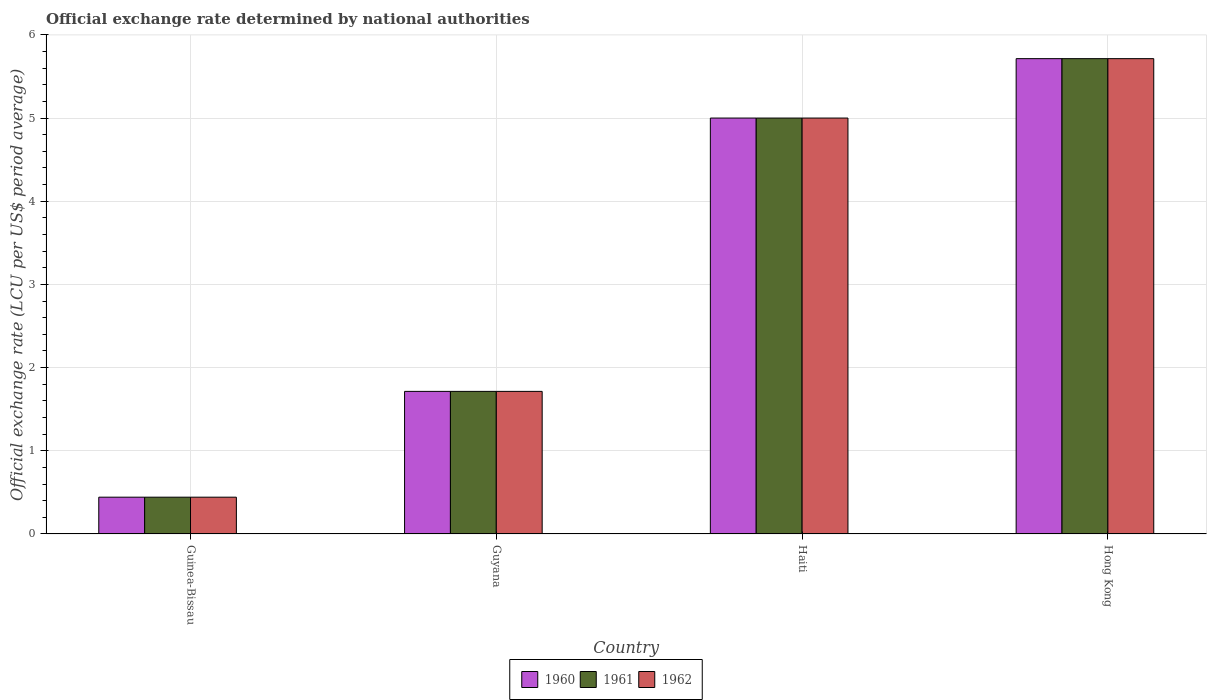Are the number of bars on each tick of the X-axis equal?
Offer a terse response. Yes. How many bars are there on the 2nd tick from the left?
Provide a short and direct response. 3. What is the label of the 1st group of bars from the left?
Make the answer very short. Guinea-Bissau. In how many cases, is the number of bars for a given country not equal to the number of legend labels?
Make the answer very short. 0. What is the official exchange rate in 1962 in Guinea-Bissau?
Give a very brief answer. 0.44. Across all countries, what is the maximum official exchange rate in 1960?
Offer a very short reply. 5.71. Across all countries, what is the minimum official exchange rate in 1960?
Make the answer very short. 0.44. In which country was the official exchange rate in 1960 maximum?
Your answer should be compact. Hong Kong. In which country was the official exchange rate in 1962 minimum?
Provide a succinct answer. Guinea-Bissau. What is the total official exchange rate in 1960 in the graph?
Your answer should be compact. 12.87. What is the difference between the official exchange rate in 1961 in Guinea-Bissau and that in Hong Kong?
Your response must be concise. -5.27. What is the difference between the official exchange rate in 1962 in Guinea-Bissau and the official exchange rate in 1961 in Guyana?
Provide a succinct answer. -1.27. What is the average official exchange rate in 1961 per country?
Offer a very short reply. 3.22. What is the difference between the official exchange rate of/in 1961 and official exchange rate of/in 1962 in Haiti?
Give a very brief answer. 0. In how many countries, is the official exchange rate in 1962 greater than 5.4 LCU?
Keep it short and to the point. 1. What is the ratio of the official exchange rate in 1961 in Haiti to that in Hong Kong?
Your answer should be compact. 0.87. Is the official exchange rate in 1960 in Guinea-Bissau less than that in Guyana?
Provide a succinct answer. Yes. Is the difference between the official exchange rate in 1961 in Guinea-Bissau and Hong Kong greater than the difference between the official exchange rate in 1962 in Guinea-Bissau and Hong Kong?
Give a very brief answer. No. What is the difference between the highest and the second highest official exchange rate in 1962?
Give a very brief answer. -3.29. What is the difference between the highest and the lowest official exchange rate in 1960?
Provide a succinct answer. 5.27. In how many countries, is the official exchange rate in 1960 greater than the average official exchange rate in 1960 taken over all countries?
Keep it short and to the point. 2. What does the 3rd bar from the right in Haiti represents?
Ensure brevity in your answer.  1960. How many bars are there?
Your response must be concise. 12. Are all the bars in the graph horizontal?
Your answer should be very brief. No. What is the difference between two consecutive major ticks on the Y-axis?
Ensure brevity in your answer.  1. Are the values on the major ticks of Y-axis written in scientific E-notation?
Provide a succinct answer. No. Does the graph contain any zero values?
Provide a succinct answer. No. Where does the legend appear in the graph?
Your response must be concise. Bottom center. How are the legend labels stacked?
Your answer should be compact. Horizontal. What is the title of the graph?
Ensure brevity in your answer.  Official exchange rate determined by national authorities. What is the label or title of the X-axis?
Give a very brief answer. Country. What is the label or title of the Y-axis?
Your answer should be very brief. Official exchange rate (LCU per US$ period average). What is the Official exchange rate (LCU per US$ period average) of 1960 in Guinea-Bissau?
Provide a short and direct response. 0.44. What is the Official exchange rate (LCU per US$ period average) in 1961 in Guinea-Bissau?
Your answer should be very brief. 0.44. What is the Official exchange rate (LCU per US$ period average) of 1962 in Guinea-Bissau?
Your answer should be compact. 0.44. What is the Official exchange rate (LCU per US$ period average) in 1960 in Guyana?
Offer a very short reply. 1.71. What is the Official exchange rate (LCU per US$ period average) of 1961 in Guyana?
Your answer should be very brief. 1.71. What is the Official exchange rate (LCU per US$ period average) in 1962 in Guyana?
Ensure brevity in your answer.  1.71. What is the Official exchange rate (LCU per US$ period average) in 1960 in Haiti?
Provide a succinct answer. 5. What is the Official exchange rate (LCU per US$ period average) of 1961 in Haiti?
Your answer should be compact. 5. What is the Official exchange rate (LCU per US$ period average) in 1962 in Haiti?
Offer a terse response. 5. What is the Official exchange rate (LCU per US$ period average) of 1960 in Hong Kong?
Your answer should be very brief. 5.71. What is the Official exchange rate (LCU per US$ period average) of 1961 in Hong Kong?
Provide a short and direct response. 5.71. What is the Official exchange rate (LCU per US$ period average) in 1962 in Hong Kong?
Offer a terse response. 5.71. Across all countries, what is the maximum Official exchange rate (LCU per US$ period average) in 1960?
Give a very brief answer. 5.71. Across all countries, what is the maximum Official exchange rate (LCU per US$ period average) in 1961?
Offer a very short reply. 5.71. Across all countries, what is the maximum Official exchange rate (LCU per US$ period average) of 1962?
Offer a terse response. 5.71. Across all countries, what is the minimum Official exchange rate (LCU per US$ period average) of 1960?
Your answer should be compact. 0.44. Across all countries, what is the minimum Official exchange rate (LCU per US$ period average) of 1961?
Provide a succinct answer. 0.44. Across all countries, what is the minimum Official exchange rate (LCU per US$ period average) in 1962?
Offer a very short reply. 0.44. What is the total Official exchange rate (LCU per US$ period average) of 1960 in the graph?
Offer a terse response. 12.87. What is the total Official exchange rate (LCU per US$ period average) of 1961 in the graph?
Your answer should be very brief. 12.87. What is the total Official exchange rate (LCU per US$ period average) of 1962 in the graph?
Ensure brevity in your answer.  12.87. What is the difference between the Official exchange rate (LCU per US$ period average) in 1960 in Guinea-Bissau and that in Guyana?
Offer a very short reply. -1.27. What is the difference between the Official exchange rate (LCU per US$ period average) of 1961 in Guinea-Bissau and that in Guyana?
Make the answer very short. -1.27. What is the difference between the Official exchange rate (LCU per US$ period average) in 1962 in Guinea-Bissau and that in Guyana?
Give a very brief answer. -1.27. What is the difference between the Official exchange rate (LCU per US$ period average) in 1960 in Guinea-Bissau and that in Haiti?
Offer a terse response. -4.56. What is the difference between the Official exchange rate (LCU per US$ period average) of 1961 in Guinea-Bissau and that in Haiti?
Provide a succinct answer. -4.56. What is the difference between the Official exchange rate (LCU per US$ period average) in 1962 in Guinea-Bissau and that in Haiti?
Make the answer very short. -4.56. What is the difference between the Official exchange rate (LCU per US$ period average) in 1960 in Guinea-Bissau and that in Hong Kong?
Your response must be concise. -5.27. What is the difference between the Official exchange rate (LCU per US$ period average) of 1961 in Guinea-Bissau and that in Hong Kong?
Keep it short and to the point. -5.27. What is the difference between the Official exchange rate (LCU per US$ period average) of 1962 in Guinea-Bissau and that in Hong Kong?
Your response must be concise. -5.27. What is the difference between the Official exchange rate (LCU per US$ period average) in 1960 in Guyana and that in Haiti?
Provide a succinct answer. -3.29. What is the difference between the Official exchange rate (LCU per US$ period average) in 1961 in Guyana and that in Haiti?
Provide a succinct answer. -3.29. What is the difference between the Official exchange rate (LCU per US$ period average) in 1962 in Guyana and that in Haiti?
Your response must be concise. -3.29. What is the difference between the Official exchange rate (LCU per US$ period average) in 1961 in Guyana and that in Hong Kong?
Provide a succinct answer. -4. What is the difference between the Official exchange rate (LCU per US$ period average) in 1960 in Haiti and that in Hong Kong?
Provide a succinct answer. -0.71. What is the difference between the Official exchange rate (LCU per US$ period average) in 1961 in Haiti and that in Hong Kong?
Keep it short and to the point. -0.71. What is the difference between the Official exchange rate (LCU per US$ period average) in 1962 in Haiti and that in Hong Kong?
Provide a succinct answer. -0.71. What is the difference between the Official exchange rate (LCU per US$ period average) in 1960 in Guinea-Bissau and the Official exchange rate (LCU per US$ period average) in 1961 in Guyana?
Keep it short and to the point. -1.27. What is the difference between the Official exchange rate (LCU per US$ period average) of 1960 in Guinea-Bissau and the Official exchange rate (LCU per US$ period average) of 1962 in Guyana?
Provide a short and direct response. -1.27. What is the difference between the Official exchange rate (LCU per US$ period average) in 1961 in Guinea-Bissau and the Official exchange rate (LCU per US$ period average) in 1962 in Guyana?
Give a very brief answer. -1.27. What is the difference between the Official exchange rate (LCU per US$ period average) of 1960 in Guinea-Bissau and the Official exchange rate (LCU per US$ period average) of 1961 in Haiti?
Your answer should be compact. -4.56. What is the difference between the Official exchange rate (LCU per US$ period average) of 1960 in Guinea-Bissau and the Official exchange rate (LCU per US$ period average) of 1962 in Haiti?
Give a very brief answer. -4.56. What is the difference between the Official exchange rate (LCU per US$ period average) of 1961 in Guinea-Bissau and the Official exchange rate (LCU per US$ period average) of 1962 in Haiti?
Offer a terse response. -4.56. What is the difference between the Official exchange rate (LCU per US$ period average) in 1960 in Guinea-Bissau and the Official exchange rate (LCU per US$ period average) in 1961 in Hong Kong?
Make the answer very short. -5.27. What is the difference between the Official exchange rate (LCU per US$ period average) in 1960 in Guinea-Bissau and the Official exchange rate (LCU per US$ period average) in 1962 in Hong Kong?
Give a very brief answer. -5.27. What is the difference between the Official exchange rate (LCU per US$ period average) of 1961 in Guinea-Bissau and the Official exchange rate (LCU per US$ period average) of 1962 in Hong Kong?
Keep it short and to the point. -5.27. What is the difference between the Official exchange rate (LCU per US$ period average) of 1960 in Guyana and the Official exchange rate (LCU per US$ period average) of 1961 in Haiti?
Provide a succinct answer. -3.29. What is the difference between the Official exchange rate (LCU per US$ period average) of 1960 in Guyana and the Official exchange rate (LCU per US$ period average) of 1962 in Haiti?
Your answer should be compact. -3.29. What is the difference between the Official exchange rate (LCU per US$ period average) in 1961 in Guyana and the Official exchange rate (LCU per US$ period average) in 1962 in Haiti?
Ensure brevity in your answer.  -3.29. What is the difference between the Official exchange rate (LCU per US$ period average) in 1960 in Guyana and the Official exchange rate (LCU per US$ period average) in 1961 in Hong Kong?
Give a very brief answer. -4. What is the difference between the Official exchange rate (LCU per US$ period average) of 1960 in Guyana and the Official exchange rate (LCU per US$ period average) of 1962 in Hong Kong?
Your response must be concise. -4. What is the difference between the Official exchange rate (LCU per US$ period average) of 1961 in Guyana and the Official exchange rate (LCU per US$ period average) of 1962 in Hong Kong?
Keep it short and to the point. -4. What is the difference between the Official exchange rate (LCU per US$ period average) in 1960 in Haiti and the Official exchange rate (LCU per US$ period average) in 1961 in Hong Kong?
Provide a short and direct response. -0.71. What is the difference between the Official exchange rate (LCU per US$ period average) in 1960 in Haiti and the Official exchange rate (LCU per US$ period average) in 1962 in Hong Kong?
Provide a succinct answer. -0.71. What is the difference between the Official exchange rate (LCU per US$ period average) of 1961 in Haiti and the Official exchange rate (LCU per US$ period average) of 1962 in Hong Kong?
Give a very brief answer. -0.71. What is the average Official exchange rate (LCU per US$ period average) in 1960 per country?
Make the answer very short. 3.22. What is the average Official exchange rate (LCU per US$ period average) of 1961 per country?
Your answer should be compact. 3.22. What is the average Official exchange rate (LCU per US$ period average) of 1962 per country?
Offer a terse response. 3.22. What is the difference between the Official exchange rate (LCU per US$ period average) of 1960 and Official exchange rate (LCU per US$ period average) of 1961 in Guinea-Bissau?
Offer a terse response. 0. What is the difference between the Official exchange rate (LCU per US$ period average) of 1960 and Official exchange rate (LCU per US$ period average) of 1962 in Guinea-Bissau?
Offer a terse response. 0. What is the difference between the Official exchange rate (LCU per US$ period average) in 1961 and Official exchange rate (LCU per US$ period average) in 1962 in Guinea-Bissau?
Provide a short and direct response. 0. What is the difference between the Official exchange rate (LCU per US$ period average) in 1960 and Official exchange rate (LCU per US$ period average) in 1961 in Guyana?
Provide a short and direct response. 0. What is the difference between the Official exchange rate (LCU per US$ period average) in 1960 and Official exchange rate (LCU per US$ period average) in 1962 in Guyana?
Provide a succinct answer. 0. What is the difference between the Official exchange rate (LCU per US$ period average) in 1961 and Official exchange rate (LCU per US$ period average) in 1962 in Guyana?
Your response must be concise. 0. What is the difference between the Official exchange rate (LCU per US$ period average) in 1960 and Official exchange rate (LCU per US$ period average) in 1961 in Haiti?
Your answer should be very brief. 0. What is the difference between the Official exchange rate (LCU per US$ period average) of 1960 and Official exchange rate (LCU per US$ period average) of 1961 in Hong Kong?
Offer a very short reply. 0. What is the ratio of the Official exchange rate (LCU per US$ period average) in 1960 in Guinea-Bissau to that in Guyana?
Keep it short and to the point. 0.26. What is the ratio of the Official exchange rate (LCU per US$ period average) of 1961 in Guinea-Bissau to that in Guyana?
Keep it short and to the point. 0.26. What is the ratio of the Official exchange rate (LCU per US$ period average) of 1962 in Guinea-Bissau to that in Guyana?
Provide a succinct answer. 0.26. What is the ratio of the Official exchange rate (LCU per US$ period average) of 1960 in Guinea-Bissau to that in Haiti?
Provide a short and direct response. 0.09. What is the ratio of the Official exchange rate (LCU per US$ period average) in 1961 in Guinea-Bissau to that in Haiti?
Give a very brief answer. 0.09. What is the ratio of the Official exchange rate (LCU per US$ period average) in 1962 in Guinea-Bissau to that in Haiti?
Ensure brevity in your answer.  0.09. What is the ratio of the Official exchange rate (LCU per US$ period average) of 1960 in Guinea-Bissau to that in Hong Kong?
Your answer should be very brief. 0.08. What is the ratio of the Official exchange rate (LCU per US$ period average) in 1961 in Guinea-Bissau to that in Hong Kong?
Your answer should be very brief. 0.08. What is the ratio of the Official exchange rate (LCU per US$ period average) of 1962 in Guinea-Bissau to that in Hong Kong?
Ensure brevity in your answer.  0.08. What is the ratio of the Official exchange rate (LCU per US$ period average) of 1960 in Guyana to that in Haiti?
Offer a terse response. 0.34. What is the ratio of the Official exchange rate (LCU per US$ period average) of 1961 in Guyana to that in Haiti?
Ensure brevity in your answer.  0.34. What is the ratio of the Official exchange rate (LCU per US$ period average) in 1962 in Guyana to that in Haiti?
Your answer should be compact. 0.34. What is the ratio of the Official exchange rate (LCU per US$ period average) of 1960 in Guyana to that in Hong Kong?
Ensure brevity in your answer.  0.3. What is the ratio of the Official exchange rate (LCU per US$ period average) of 1962 in Haiti to that in Hong Kong?
Ensure brevity in your answer.  0.88. What is the difference between the highest and the second highest Official exchange rate (LCU per US$ period average) in 1961?
Keep it short and to the point. 0.71. What is the difference between the highest and the second highest Official exchange rate (LCU per US$ period average) in 1962?
Offer a terse response. 0.71. What is the difference between the highest and the lowest Official exchange rate (LCU per US$ period average) of 1960?
Provide a short and direct response. 5.27. What is the difference between the highest and the lowest Official exchange rate (LCU per US$ period average) of 1961?
Give a very brief answer. 5.27. What is the difference between the highest and the lowest Official exchange rate (LCU per US$ period average) in 1962?
Your answer should be very brief. 5.27. 